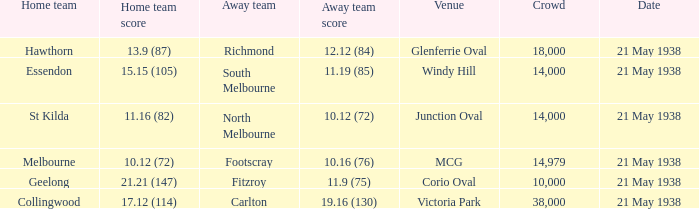Which Away team has a Crowd larger than 14,000, and a Home team of melbourne? Footscray. 